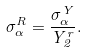<formula> <loc_0><loc_0><loc_500><loc_500>\sigma ^ { R } _ { \alpha } = \frac { \sigma ^ { Y } _ { \alpha } } { Y ^ { r } _ { 2 } } .</formula> 